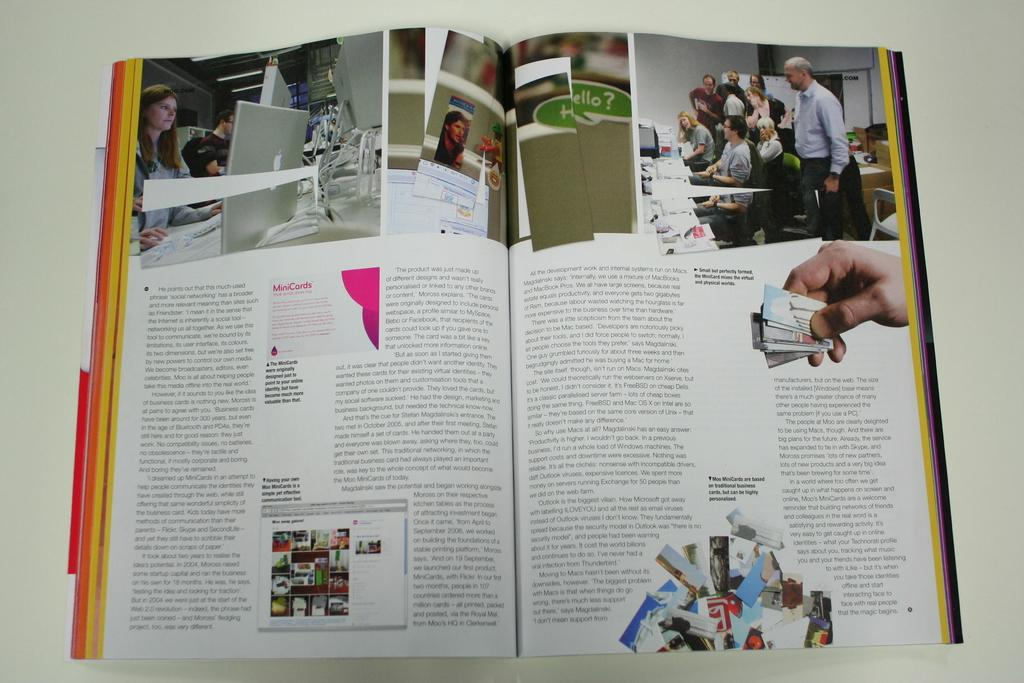<image>
Give a short and clear explanation of the subsequent image. An open book laying on a table with information about schools and pictures of classroom time and one picture says hello. 